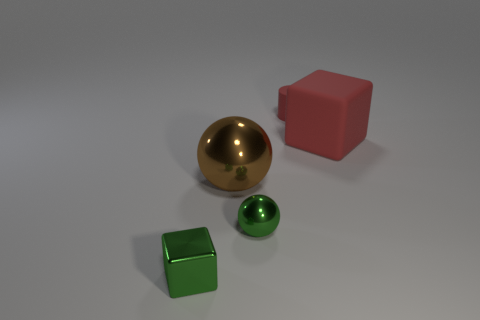How is the lighting arranged in the scene? The lighting in the scene appears to come from above, given the shadows cast directly underneath and slightly to the side of each object. The soft nature of the shadows suggests the light source is diffused, contributing to the gentle illumination and subtle reflections on the objects. Does the lighting indicate anything about the time of day or setting? Given the controlled and uniform lighting, it seems more indicative of an indoor photo shoot or an artificial environment rather than a natural outdoor setting or a specific time of day. 